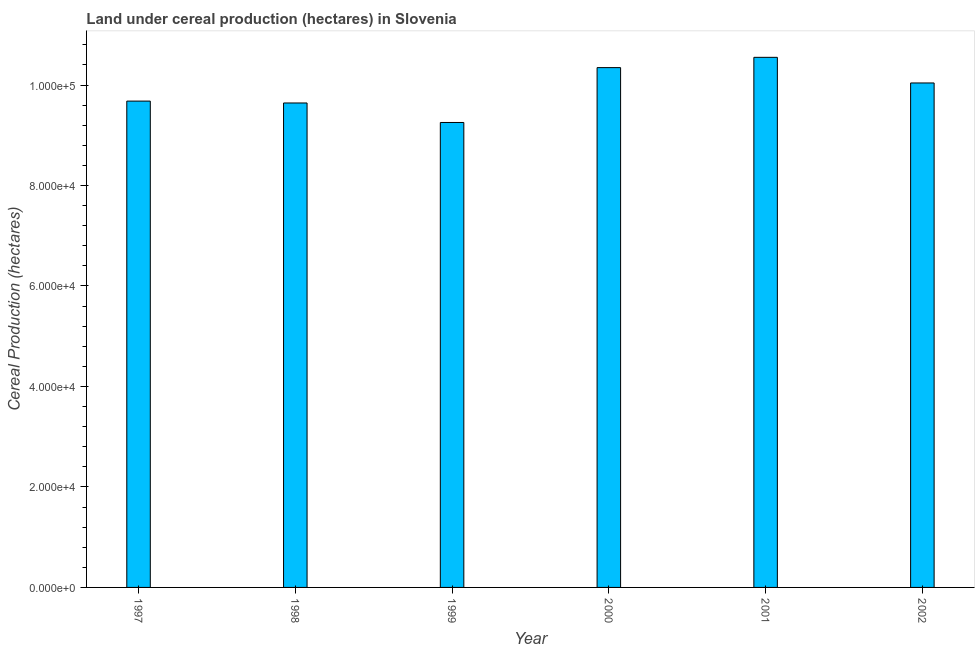Does the graph contain any zero values?
Ensure brevity in your answer.  No. What is the title of the graph?
Offer a very short reply. Land under cereal production (hectares) in Slovenia. What is the label or title of the Y-axis?
Your answer should be compact. Cereal Production (hectares). What is the land under cereal production in 2000?
Your answer should be very brief. 1.03e+05. Across all years, what is the maximum land under cereal production?
Provide a succinct answer. 1.06e+05. Across all years, what is the minimum land under cereal production?
Your answer should be compact. 9.25e+04. In which year was the land under cereal production maximum?
Ensure brevity in your answer.  2001. In which year was the land under cereal production minimum?
Your response must be concise. 1999. What is the sum of the land under cereal production?
Offer a terse response. 5.95e+05. What is the difference between the land under cereal production in 1997 and 1998?
Give a very brief answer. 372. What is the average land under cereal production per year?
Offer a very short reply. 9.92e+04. What is the median land under cereal production?
Offer a terse response. 9.86e+04. In how many years, is the land under cereal production greater than 72000 hectares?
Your answer should be compact. 6. What is the ratio of the land under cereal production in 1999 to that in 2002?
Your response must be concise. 0.92. Is the difference between the land under cereal production in 1998 and 2000 greater than the difference between any two years?
Your answer should be very brief. No. What is the difference between the highest and the second highest land under cereal production?
Your answer should be very brief. 2048. Is the sum of the land under cereal production in 2000 and 2001 greater than the maximum land under cereal production across all years?
Your answer should be compact. Yes. What is the difference between the highest and the lowest land under cereal production?
Your answer should be compact. 1.30e+04. How many bars are there?
Your answer should be compact. 6. Are all the bars in the graph horizontal?
Offer a very short reply. No. Are the values on the major ticks of Y-axis written in scientific E-notation?
Your response must be concise. Yes. What is the Cereal Production (hectares) of 1997?
Make the answer very short. 9.68e+04. What is the Cereal Production (hectares) of 1998?
Offer a terse response. 9.64e+04. What is the Cereal Production (hectares) in 1999?
Provide a succinct answer. 9.25e+04. What is the Cereal Production (hectares) of 2000?
Give a very brief answer. 1.03e+05. What is the Cereal Production (hectares) in 2001?
Provide a succinct answer. 1.06e+05. What is the Cereal Production (hectares) in 2002?
Offer a very short reply. 1.00e+05. What is the difference between the Cereal Production (hectares) in 1997 and 1998?
Offer a very short reply. 372. What is the difference between the Cereal Production (hectares) in 1997 and 1999?
Your answer should be compact. 4253. What is the difference between the Cereal Production (hectares) in 1997 and 2000?
Offer a very short reply. -6666. What is the difference between the Cereal Production (hectares) in 1997 and 2001?
Make the answer very short. -8714. What is the difference between the Cereal Production (hectares) in 1997 and 2002?
Offer a terse response. -3612. What is the difference between the Cereal Production (hectares) in 1998 and 1999?
Your answer should be compact. 3881. What is the difference between the Cereal Production (hectares) in 1998 and 2000?
Provide a succinct answer. -7038. What is the difference between the Cereal Production (hectares) in 1998 and 2001?
Your answer should be very brief. -9086. What is the difference between the Cereal Production (hectares) in 1998 and 2002?
Provide a succinct answer. -3984. What is the difference between the Cereal Production (hectares) in 1999 and 2000?
Make the answer very short. -1.09e+04. What is the difference between the Cereal Production (hectares) in 1999 and 2001?
Give a very brief answer. -1.30e+04. What is the difference between the Cereal Production (hectares) in 1999 and 2002?
Your response must be concise. -7865. What is the difference between the Cereal Production (hectares) in 2000 and 2001?
Your answer should be very brief. -2048. What is the difference between the Cereal Production (hectares) in 2000 and 2002?
Provide a short and direct response. 3054. What is the difference between the Cereal Production (hectares) in 2001 and 2002?
Provide a succinct answer. 5102. What is the ratio of the Cereal Production (hectares) in 1997 to that in 1999?
Your response must be concise. 1.05. What is the ratio of the Cereal Production (hectares) in 1997 to that in 2000?
Give a very brief answer. 0.94. What is the ratio of the Cereal Production (hectares) in 1997 to that in 2001?
Give a very brief answer. 0.92. What is the ratio of the Cereal Production (hectares) in 1997 to that in 2002?
Provide a short and direct response. 0.96. What is the ratio of the Cereal Production (hectares) in 1998 to that in 1999?
Offer a terse response. 1.04. What is the ratio of the Cereal Production (hectares) in 1998 to that in 2000?
Ensure brevity in your answer.  0.93. What is the ratio of the Cereal Production (hectares) in 1998 to that in 2001?
Your answer should be very brief. 0.91. What is the ratio of the Cereal Production (hectares) in 1998 to that in 2002?
Provide a short and direct response. 0.96. What is the ratio of the Cereal Production (hectares) in 1999 to that in 2000?
Make the answer very short. 0.89. What is the ratio of the Cereal Production (hectares) in 1999 to that in 2001?
Your answer should be very brief. 0.88. What is the ratio of the Cereal Production (hectares) in 1999 to that in 2002?
Offer a very short reply. 0.92. What is the ratio of the Cereal Production (hectares) in 2000 to that in 2002?
Offer a very short reply. 1.03. What is the ratio of the Cereal Production (hectares) in 2001 to that in 2002?
Provide a succinct answer. 1.05. 